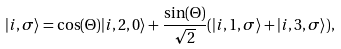Convert formula to latex. <formula><loc_0><loc_0><loc_500><loc_500>| i , \sigma \rangle = \cos ( \Theta ) | i , 2 , 0 \rangle + \frac { \sin ( \Theta ) } { \sqrt { 2 } } ( | i , 1 , \sigma \rangle + | i , 3 , \sigma \rangle ) ,</formula> 